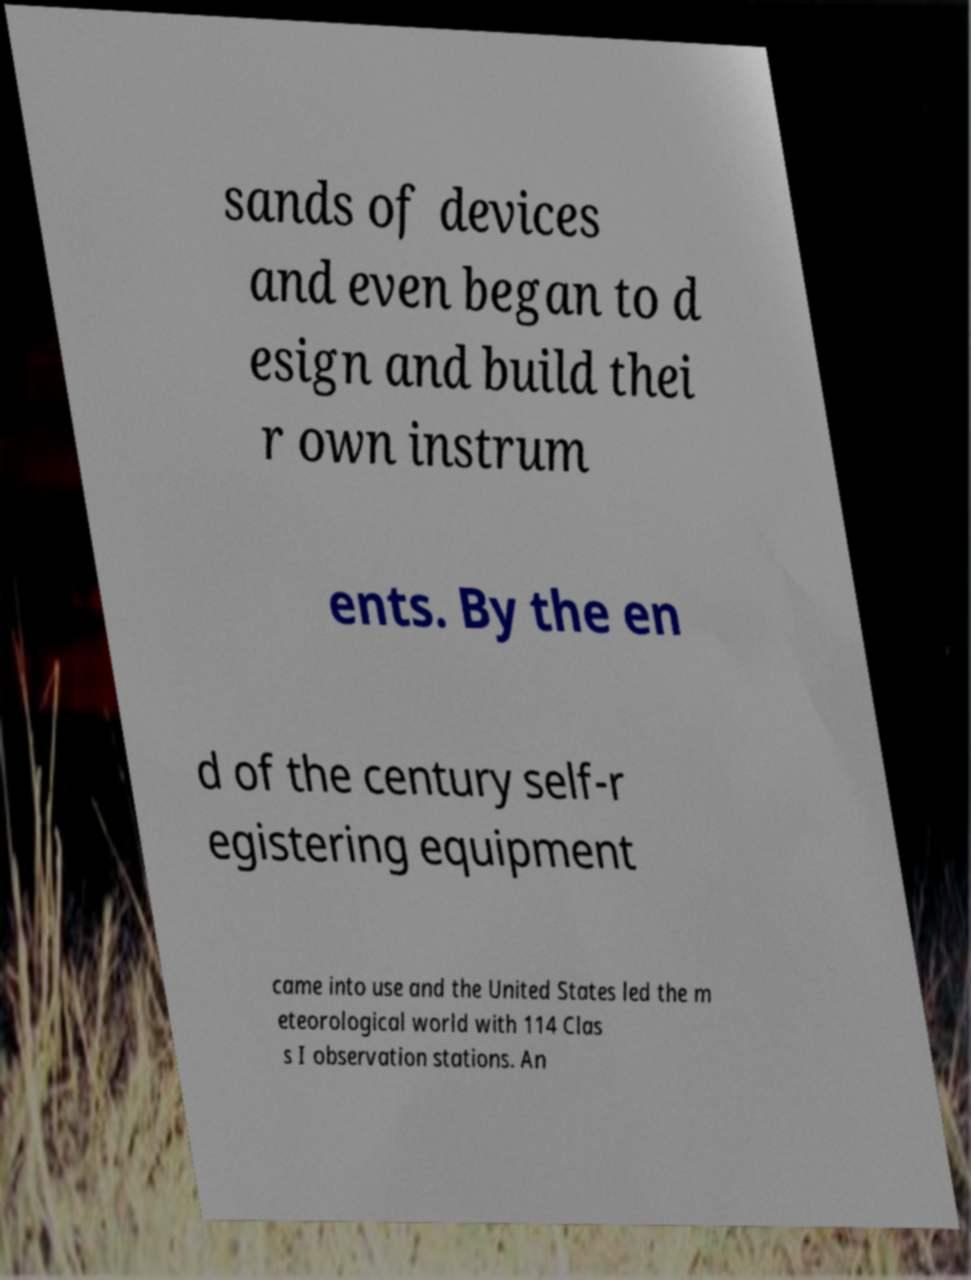Can you read and provide the text displayed in the image?This photo seems to have some interesting text. Can you extract and type it out for me? sands of devices and even began to d esign and build thei r own instrum ents. By the en d of the century self-r egistering equipment came into use and the United States led the m eteorological world with 114 Clas s I observation stations. An 